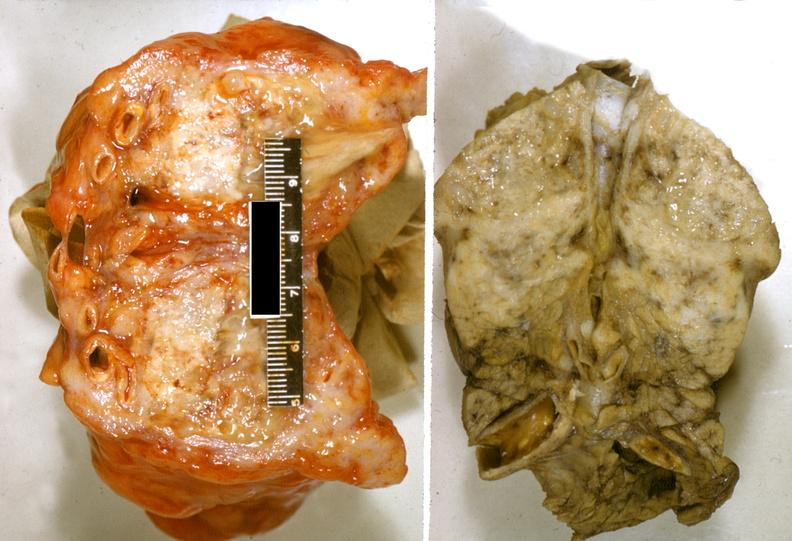does this image show adenocarcinoma, tail of pancreas?
Answer the question using a single word or phrase. Yes 